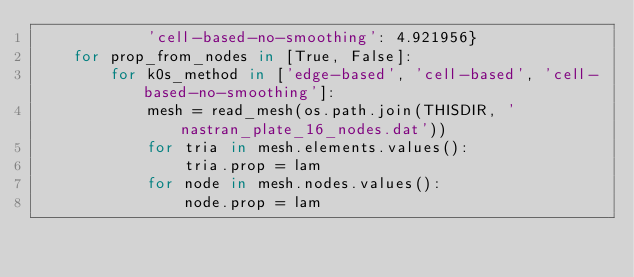<code> <loc_0><loc_0><loc_500><loc_500><_Python_>            'cell-based-no-smoothing': 4.921956}
    for prop_from_nodes in [True, False]:
        for k0s_method in ['edge-based', 'cell-based', 'cell-based-no-smoothing']:
            mesh = read_mesh(os.path.join(THISDIR, 'nastran_plate_16_nodes.dat'))
            for tria in mesh.elements.values():
                tria.prop = lam
            for node in mesh.nodes.values():
                node.prop = lam</code> 